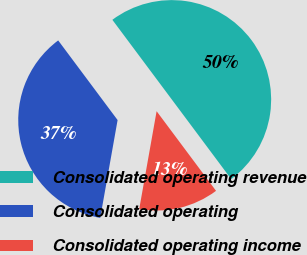<chart> <loc_0><loc_0><loc_500><loc_500><pie_chart><fcel>Consolidated operating revenue<fcel>Consolidated operating<fcel>Consolidated operating income<nl><fcel>50.0%<fcel>37.0%<fcel>13.0%<nl></chart> 